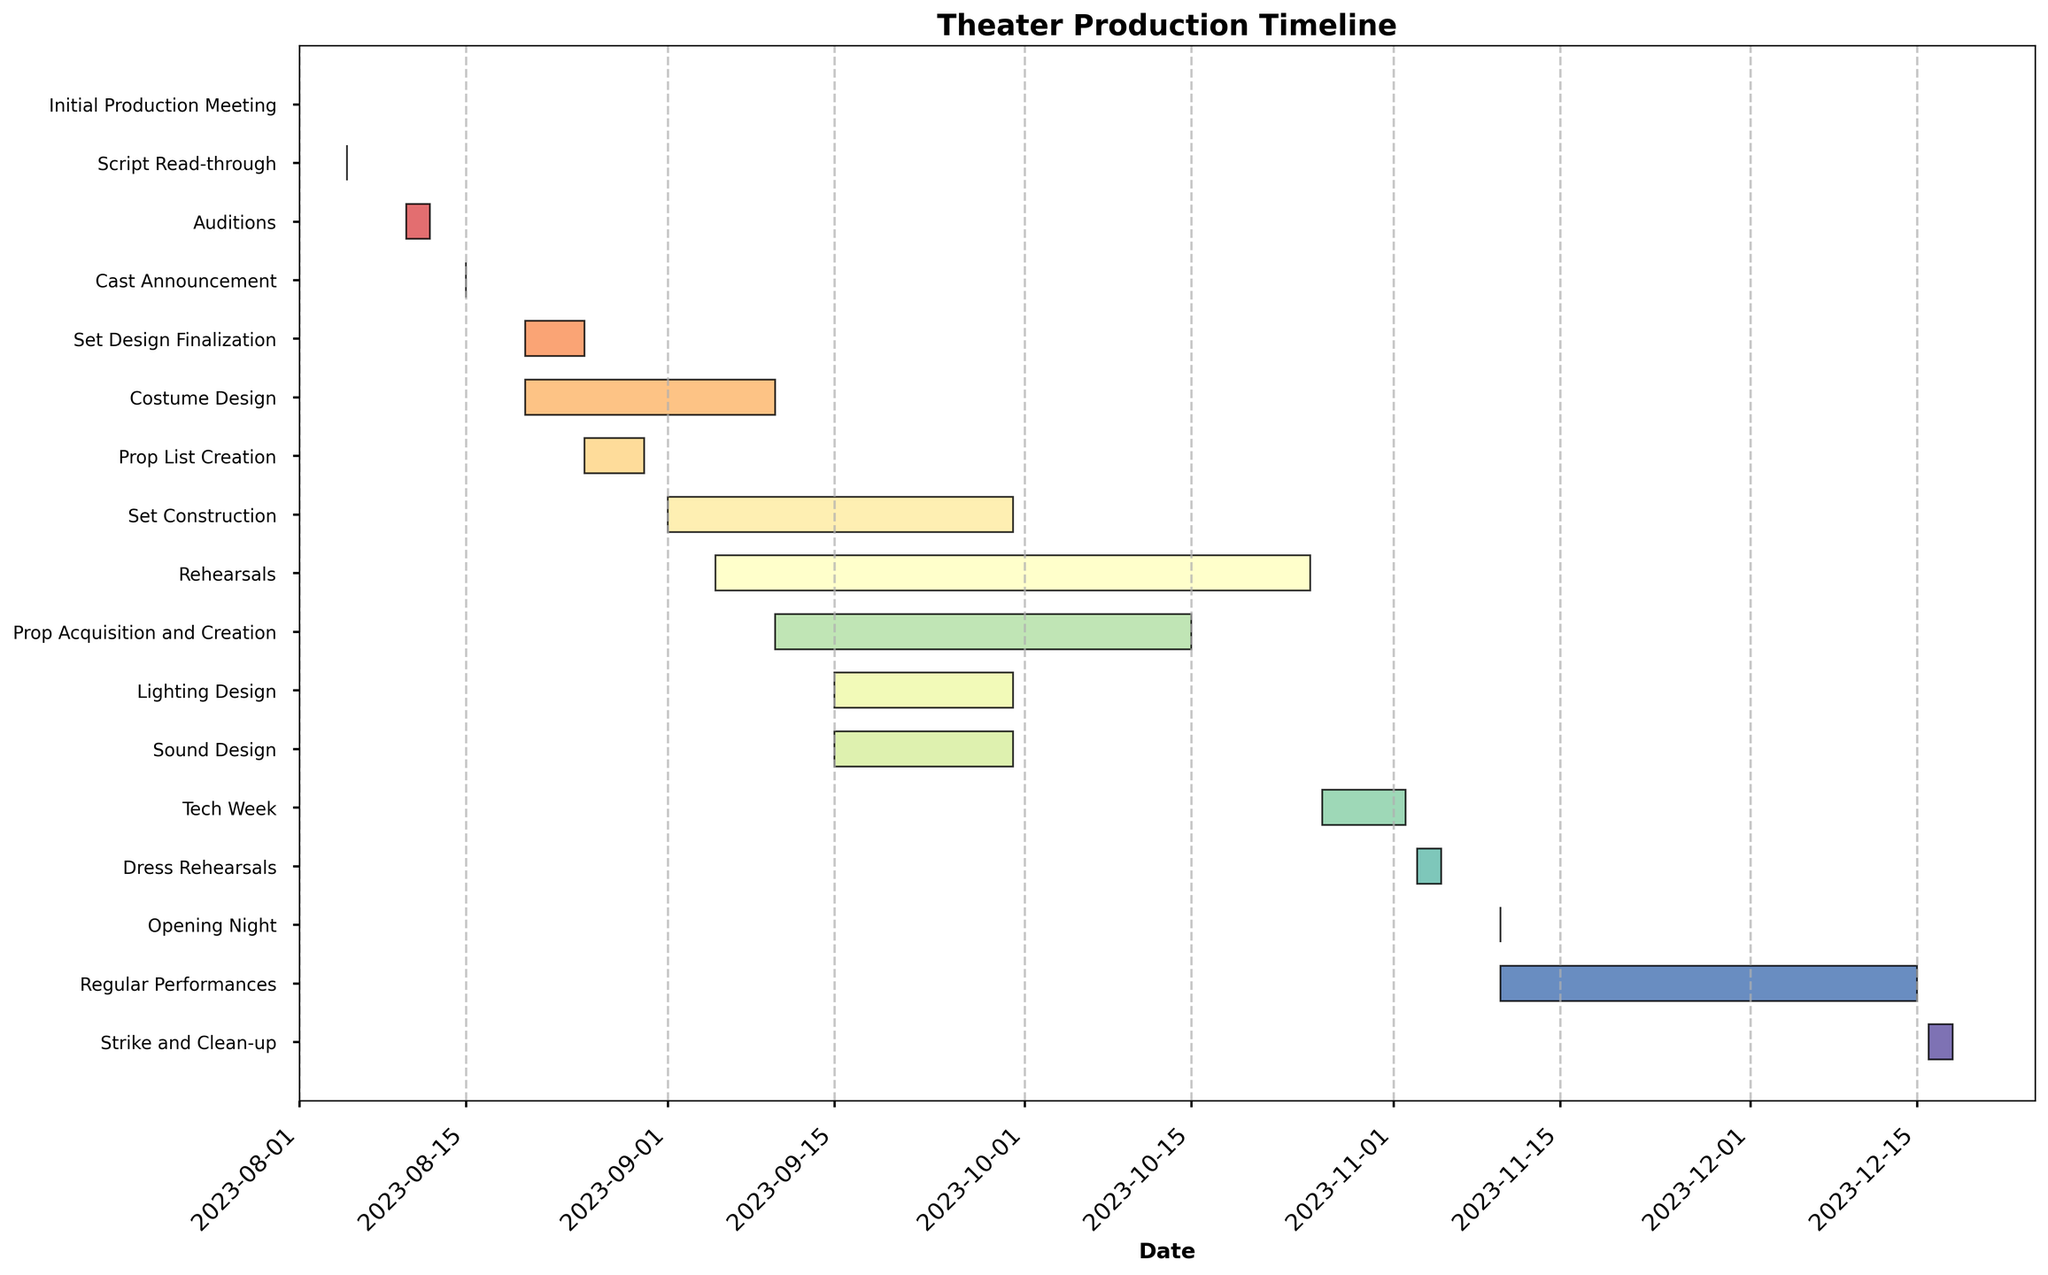What is the title of the plot? The title can be found at the top of the chart. It is usually in a larger and bolder font compared to other text.
Answer: Theater Production Timeline Which task starts first? The task that starts first is the one with the earliest start date. You can identify it by looking at the leftmost bar on the x-axis corresponding to the earliest date.
Answer: Initial Production Meeting How many tasks are there in total? Count the number of horizontal bars in the chart, as each bar represents a task.
Answer: 16 During which month does the Set Design Finalization occur? Locate the bar labeled "Set Design Finalization" and check the dates that it covers.
Answer: August How long does the Set Construction last? Measure the duration of the horizontal bar labeled "Set Construction" by calculating the difference between its start and end dates.
Answer: 30 days Which tasks overlap with Rehearsals? Identify the bar labeled "Rehearsals" and look for other bars that intersect with its timeline.
Answer: Set Construction, Lighting Design, Sound Design, Prop Acquisition and Creation Which tasks are shorter than a week? Examine the duration of all tasks and identify those with a length of 7 days or less by comparing their start and end dates.
Answer: Initial Production Meeting, Script Read-through, Auditions, Cast Announcement, Prop List Creation What is the duration of the longest task? Examine the durations of all tasks and identify the one with the maximum length by measuring the time span from start to end dates.
Answer: Regular Performances (35 days) How many tasks start in September? Count the number of tasks whose start dates fall within the month of September.
Answer: 5 Which task ends immediately before Opening Night? Look for the task that finishes closest to the date of the Opening Night but before it.
Answer: Dress Rehearsals 